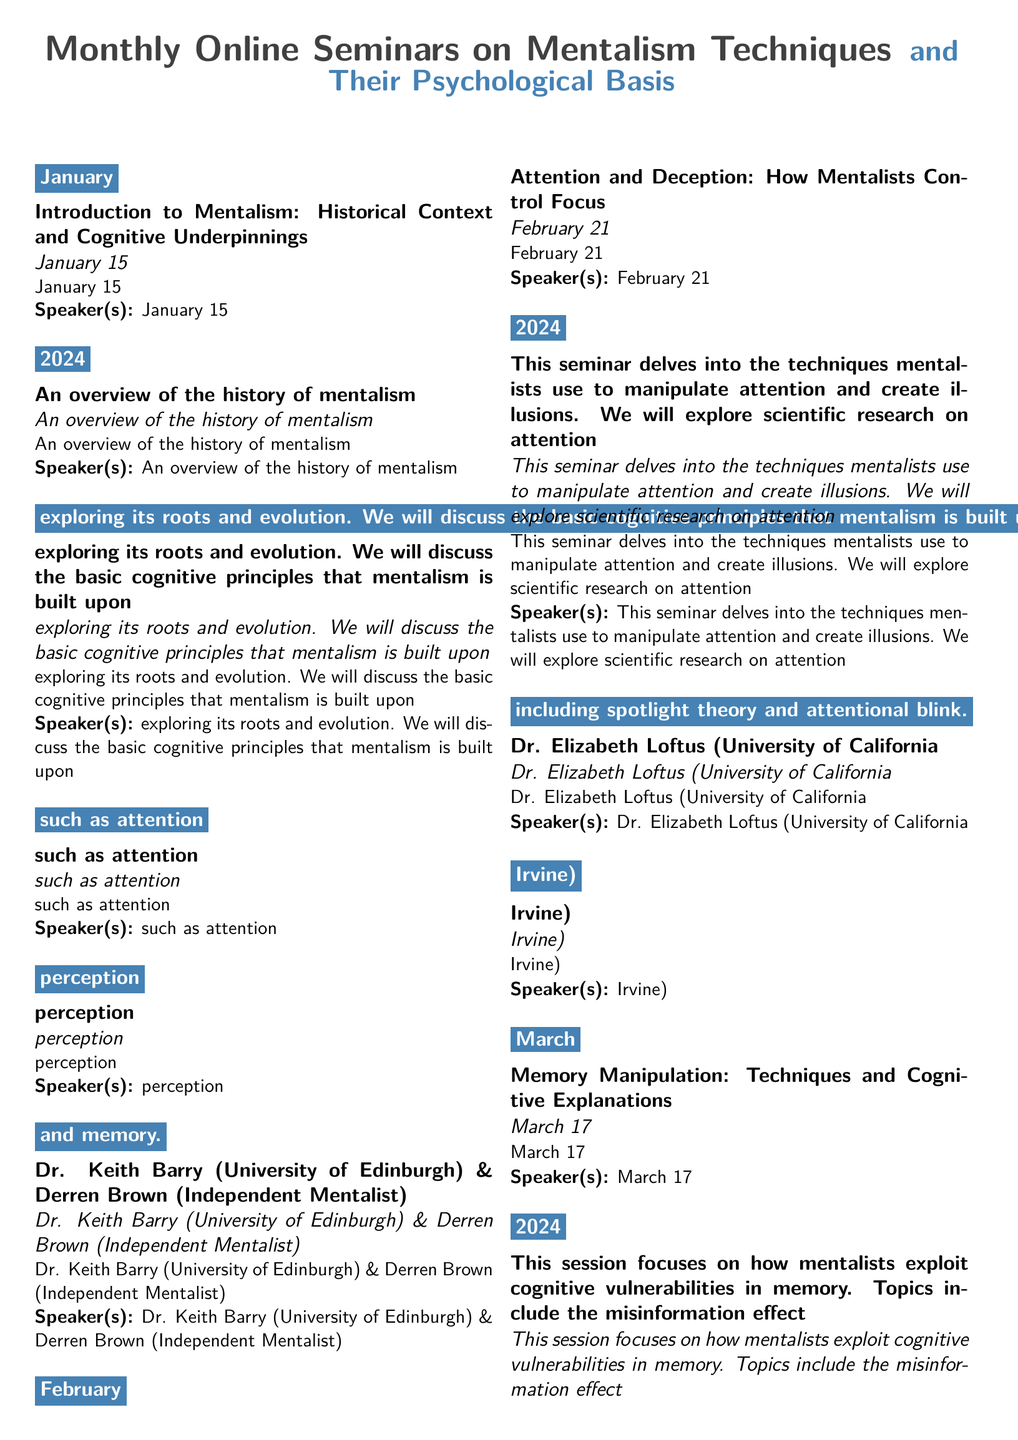what is the date of the seminar on Memory Manipulation? The seminar on Memory Manipulation is scheduled for March 17, 2024.
Answer: March 17, 2024 who is the speaker for the seminar on Attention and Deception? The speaker for the seminar on Attention and Deception is Dr. Elizabeth Loftus (University of California, Irvine).
Answer: Dr. Elizabeth Loftus what topic is covered in May's seminar? The topic covered in May's seminar is Nonverbal Communication: Reading and Projecting Cues.
Answer: Nonverbal Communication: Reading and Projecting Cues which month features the seminar on The Psychology of Suggestion and Influence? The Psychology of Suggestion and Influence seminar is in April.
Answer: April how many seminars are listed in the document? There are five seminars listed in the document.
Answer: five who are the speakers for the January seminar? The speakers for the January seminar are Dr. Keith Barry (University of Edinburgh) and Derren Brown (Independent Mentalist).
Answer: Dr. Keith Barry and Derren Brown what cognitive principle is discussed in relation to memory manipulation? The cognitive vulnerabilities in memory are discussed, including the misinformation effect and false memories.
Answer: misinformation effect what is the title of the February seminar? The title of the February seminar is Attention and Deception: How Mentalists Control Focus.
Answer: Attention and Deception: How Mentalists Control Focus 